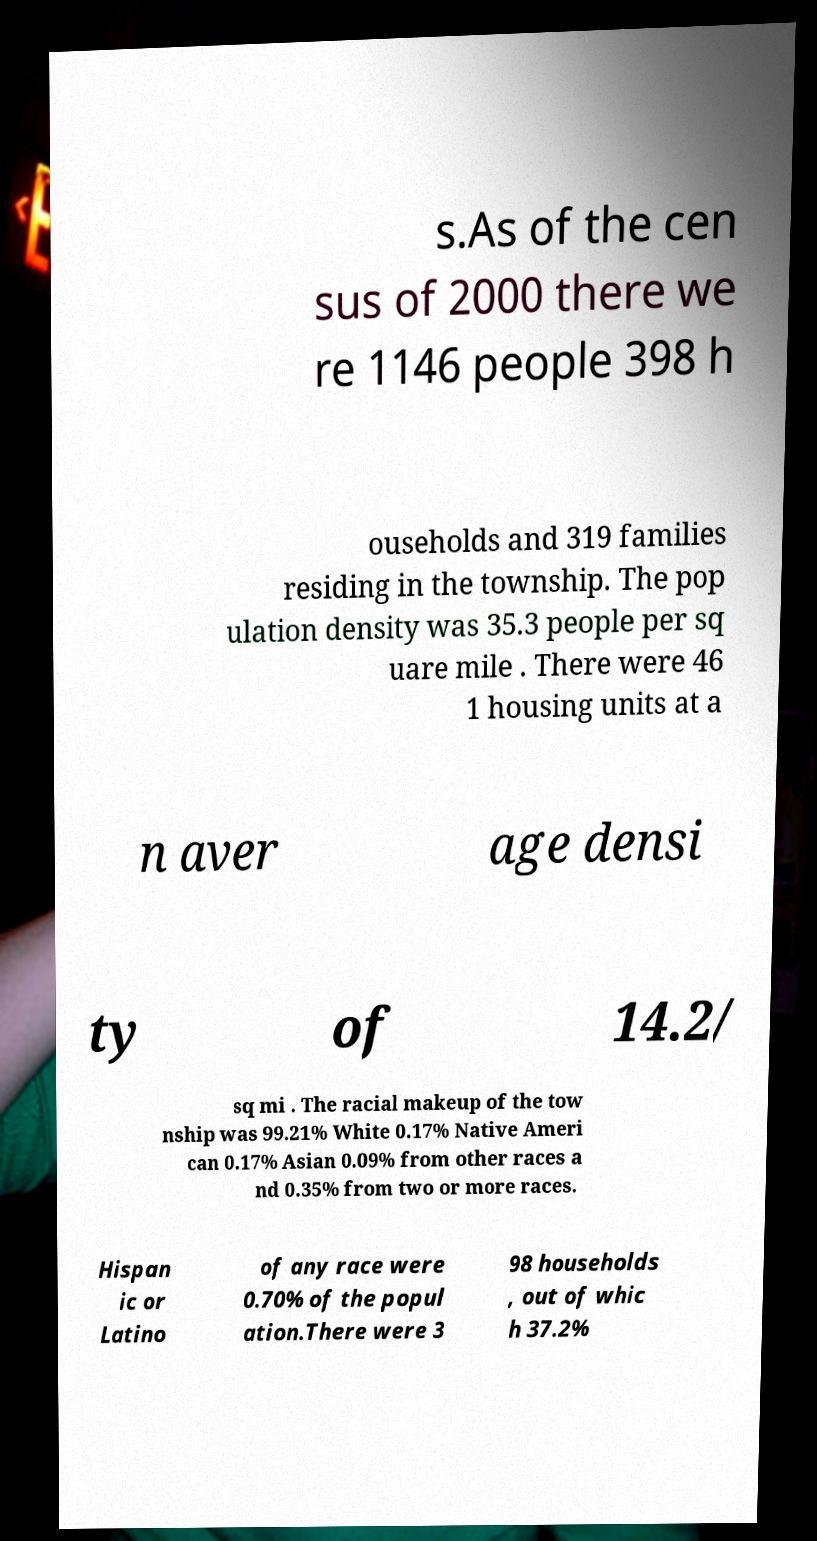For documentation purposes, I need the text within this image transcribed. Could you provide that? s.As of the cen sus of 2000 there we re 1146 people 398 h ouseholds and 319 families residing in the township. The pop ulation density was 35.3 people per sq uare mile . There were 46 1 housing units at a n aver age densi ty of 14.2/ sq mi . The racial makeup of the tow nship was 99.21% White 0.17% Native Ameri can 0.17% Asian 0.09% from other races a nd 0.35% from two or more races. Hispan ic or Latino of any race were 0.70% of the popul ation.There were 3 98 households , out of whic h 37.2% 